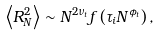<formula> <loc_0><loc_0><loc_500><loc_500>\left \langle R _ { N } ^ { 2 } \right \rangle \sim N ^ { 2 \nu _ { t } } f \left ( \tau _ { i } N ^ { \phi _ { t } } \right ) ,</formula> 